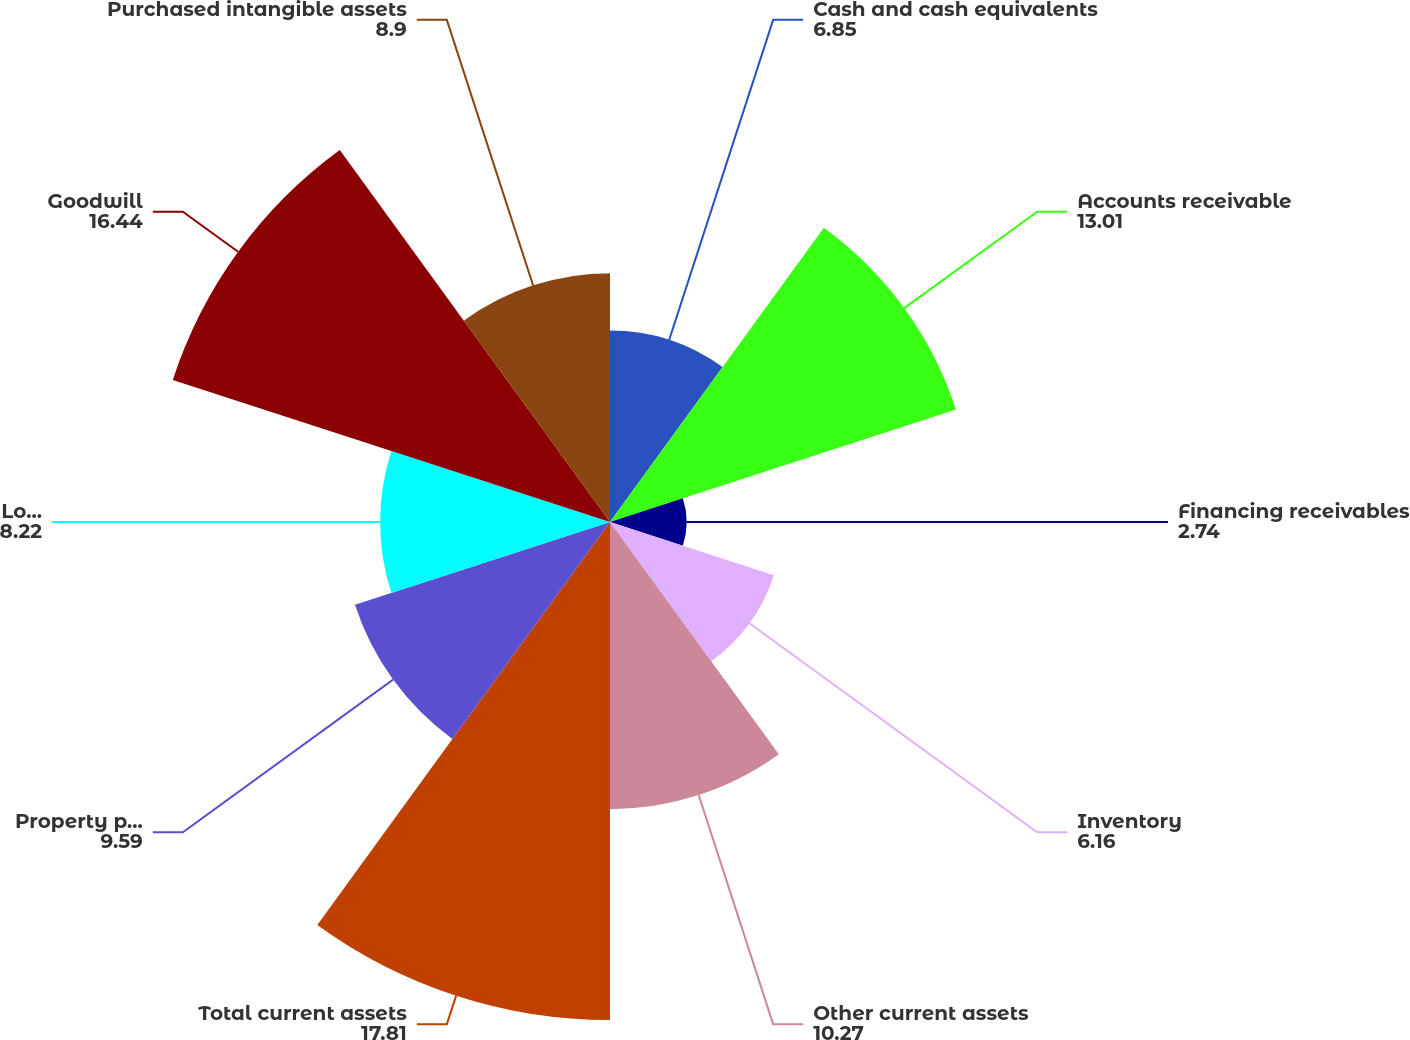Convert chart. <chart><loc_0><loc_0><loc_500><loc_500><pie_chart><fcel>Cash and cash equivalents<fcel>Accounts receivable<fcel>Financing receivables<fcel>Inventory<fcel>Other current assets<fcel>Total current assets<fcel>Property plant and equipment<fcel>Long-term financing<fcel>Goodwill<fcel>Purchased intangible assets<nl><fcel>6.85%<fcel>13.01%<fcel>2.74%<fcel>6.16%<fcel>10.27%<fcel>17.81%<fcel>9.59%<fcel>8.22%<fcel>16.44%<fcel>8.9%<nl></chart> 